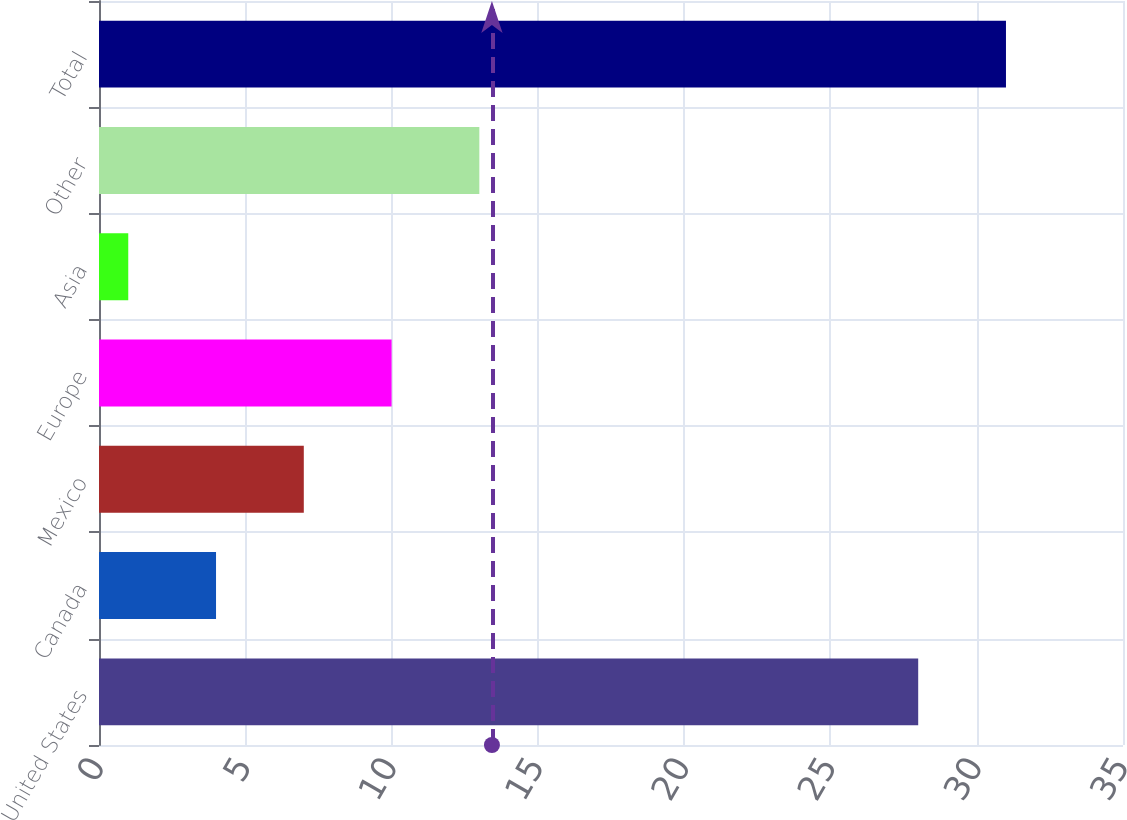Convert chart. <chart><loc_0><loc_0><loc_500><loc_500><bar_chart><fcel>United States<fcel>Canada<fcel>Mexico<fcel>Europe<fcel>Asia<fcel>Other<fcel>Total<nl><fcel>28<fcel>4<fcel>7<fcel>10<fcel>1<fcel>13<fcel>31<nl></chart> 